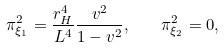Convert formula to latex. <formula><loc_0><loc_0><loc_500><loc_500>\pi _ { \xi _ { 1 } } ^ { 2 } = \frac { r _ { H } ^ { 4 } } { L ^ { 4 } } \frac { v ^ { 2 } } { 1 - v ^ { 2 } } , \quad \pi _ { \xi _ { 2 } } ^ { 2 } = 0 ,</formula> 